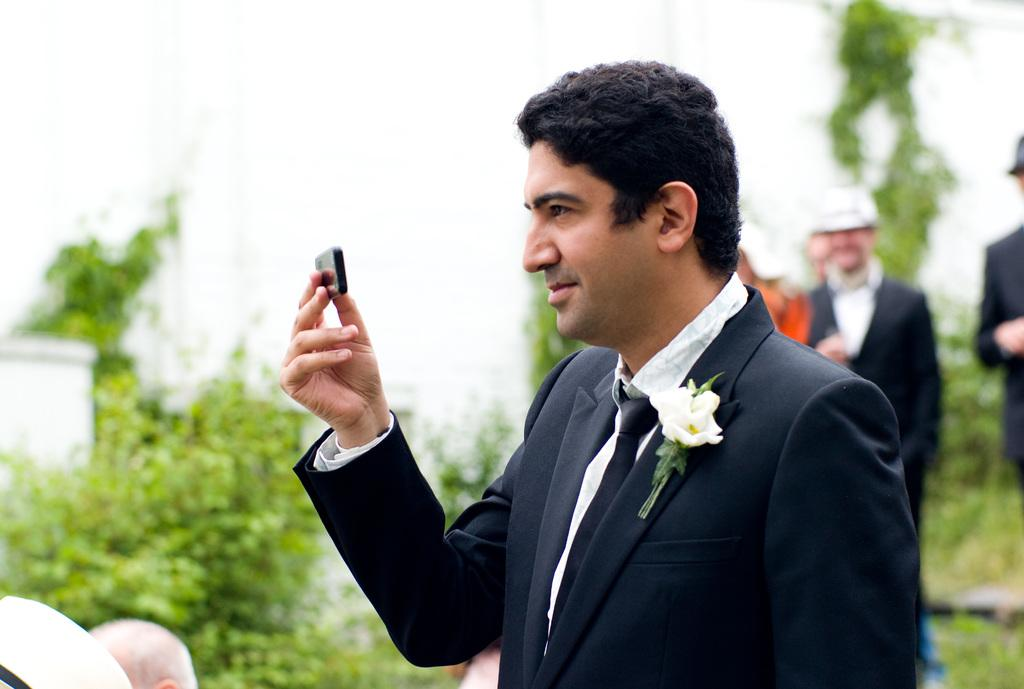Who is the main subject in the image? There is a man in the image. What is the man doing in the image? The man is standing in front. What is the man holding in his hand? The man is holding a black object in his hand. What can be seen in the background of the image? There are people and plants in the background of the image. Can you see any chalk or a tray in the image? No, there is no chalk or tray present in the image. Is there a lake visible in the background of the image? No, there is no lake visible in the image; only people and plants can be seen in the background. 